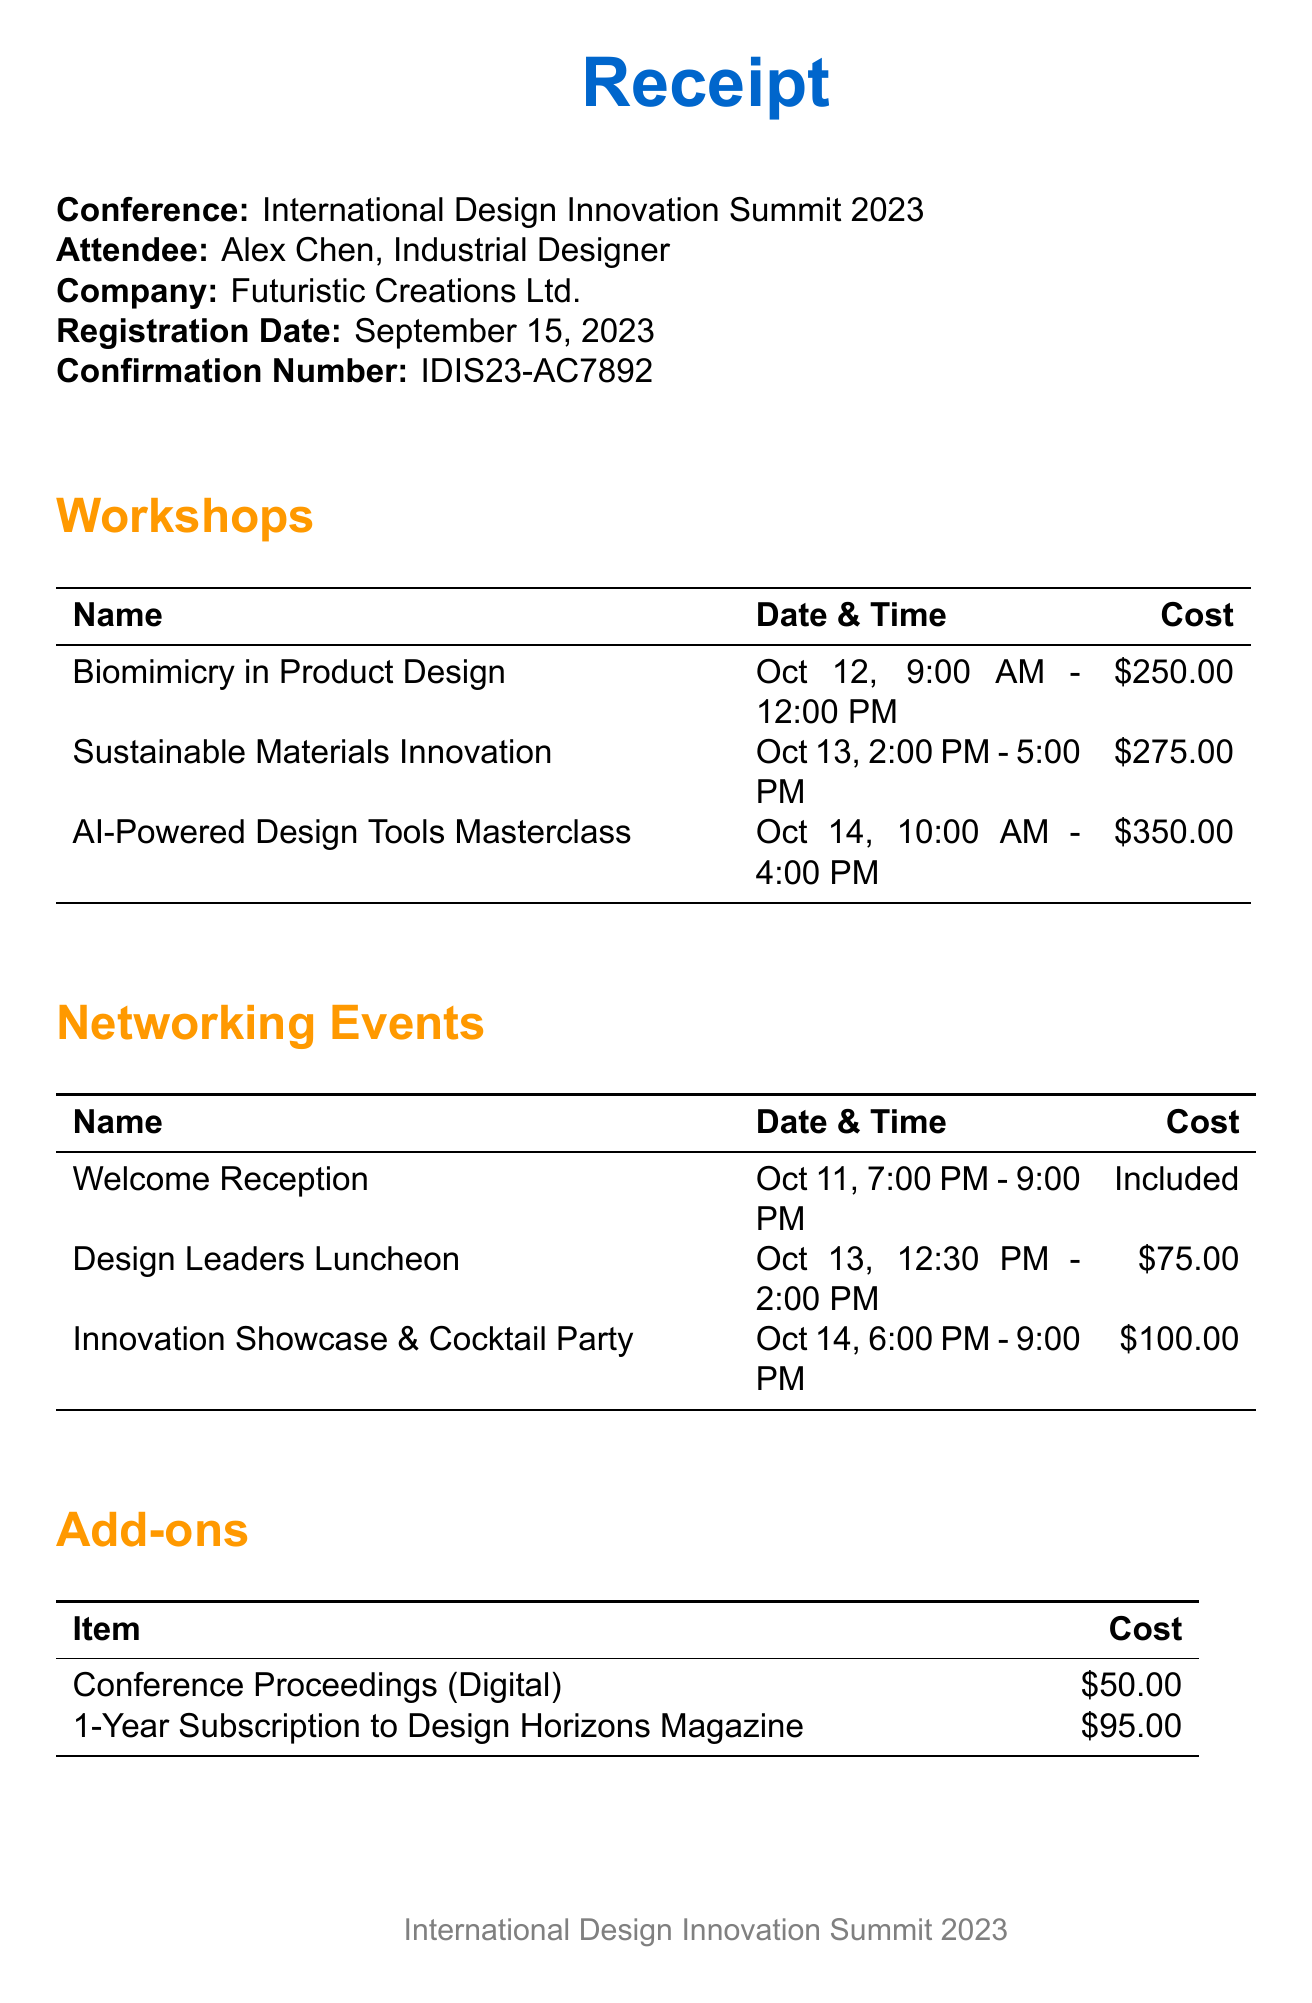What is the name of the conference? The document states the conference name at the beginning, which is International Design Innovation Summit 2023.
Answer: International Design Innovation Summit 2023 Who is the instructor for the workshop on Sustainable Materials Innovation? The instructor for this workshop is listed alongside the workshop name and date in the workshops section.
Answer: Prof. Michael Braungart What is the cost of the AI-Powered Design Tools Masterclass workshop? The cost is mentioned directly next to the workshop name and details.
Answer: $350.00 When is the Design Leaders Luncheon scheduled? The date and time for this networking event are listed in the networking events section.
Answer: October 13, 12:30 PM - 2:00 PM What is the total cost of the conference registration? The total cost is prominently stated at the end of the receipt.
Answer: $1,495.00 What payment method was used for the registration? The payment method is stated towards the end of the document.
Answer: Credit Card How many workshops are listed in the document? The number of workshops can be counted by looking at the workshops section.
Answer: 3 What is included with the Welcome Reception? The document states the cost for the Welcome Reception as "Included," indicating it is part of the registration.
Answer: Included What is the confirmation number for the registration? The confirmation number is provided in the registration details section on the document.
Answer: IDIS23-AC7892 